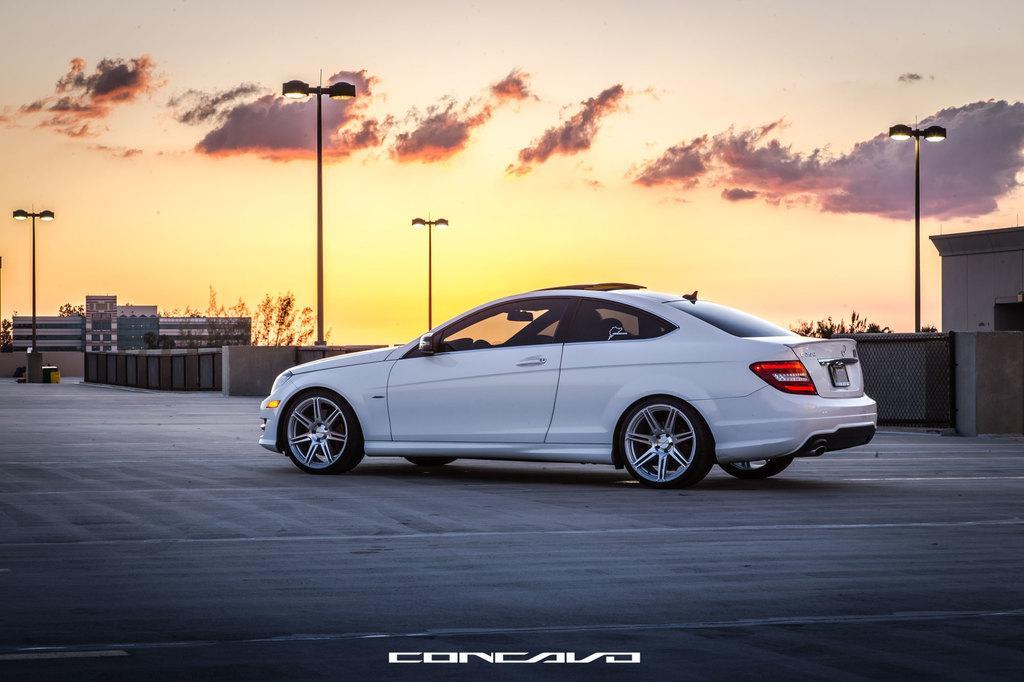Could you give a brief overview of what you see in this image? In the middle of the picture, we see a white car is moving on the road. At the bottom, we see the road and we see some text written. Behind the car, we see a wall and the street lights. On the right side, we see a building, street lights and a tree. On the left side, we see the street lights, buildings and trees. At the top, we see the sky and the clouds. This might be an edited image. 